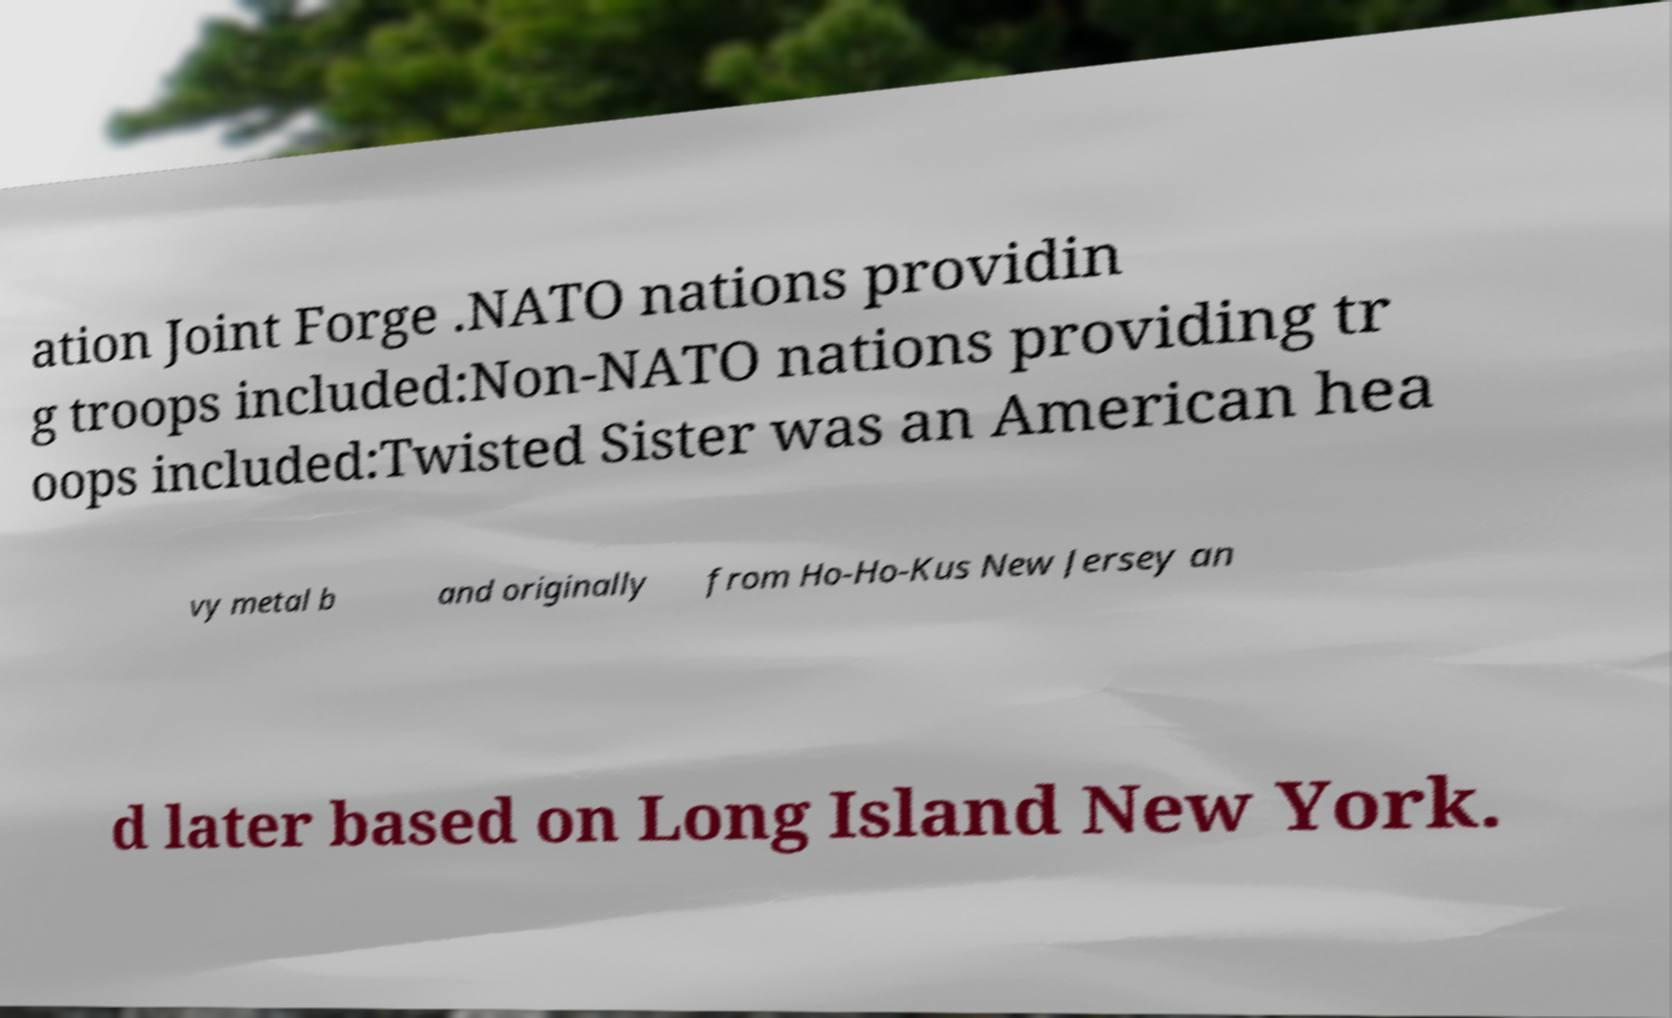For documentation purposes, I need the text within this image transcribed. Could you provide that? ation Joint Forge .NATO nations providin g troops included:Non-NATO nations providing tr oops included:Twisted Sister was an American hea vy metal b and originally from Ho-Ho-Kus New Jersey an d later based on Long Island New York. 